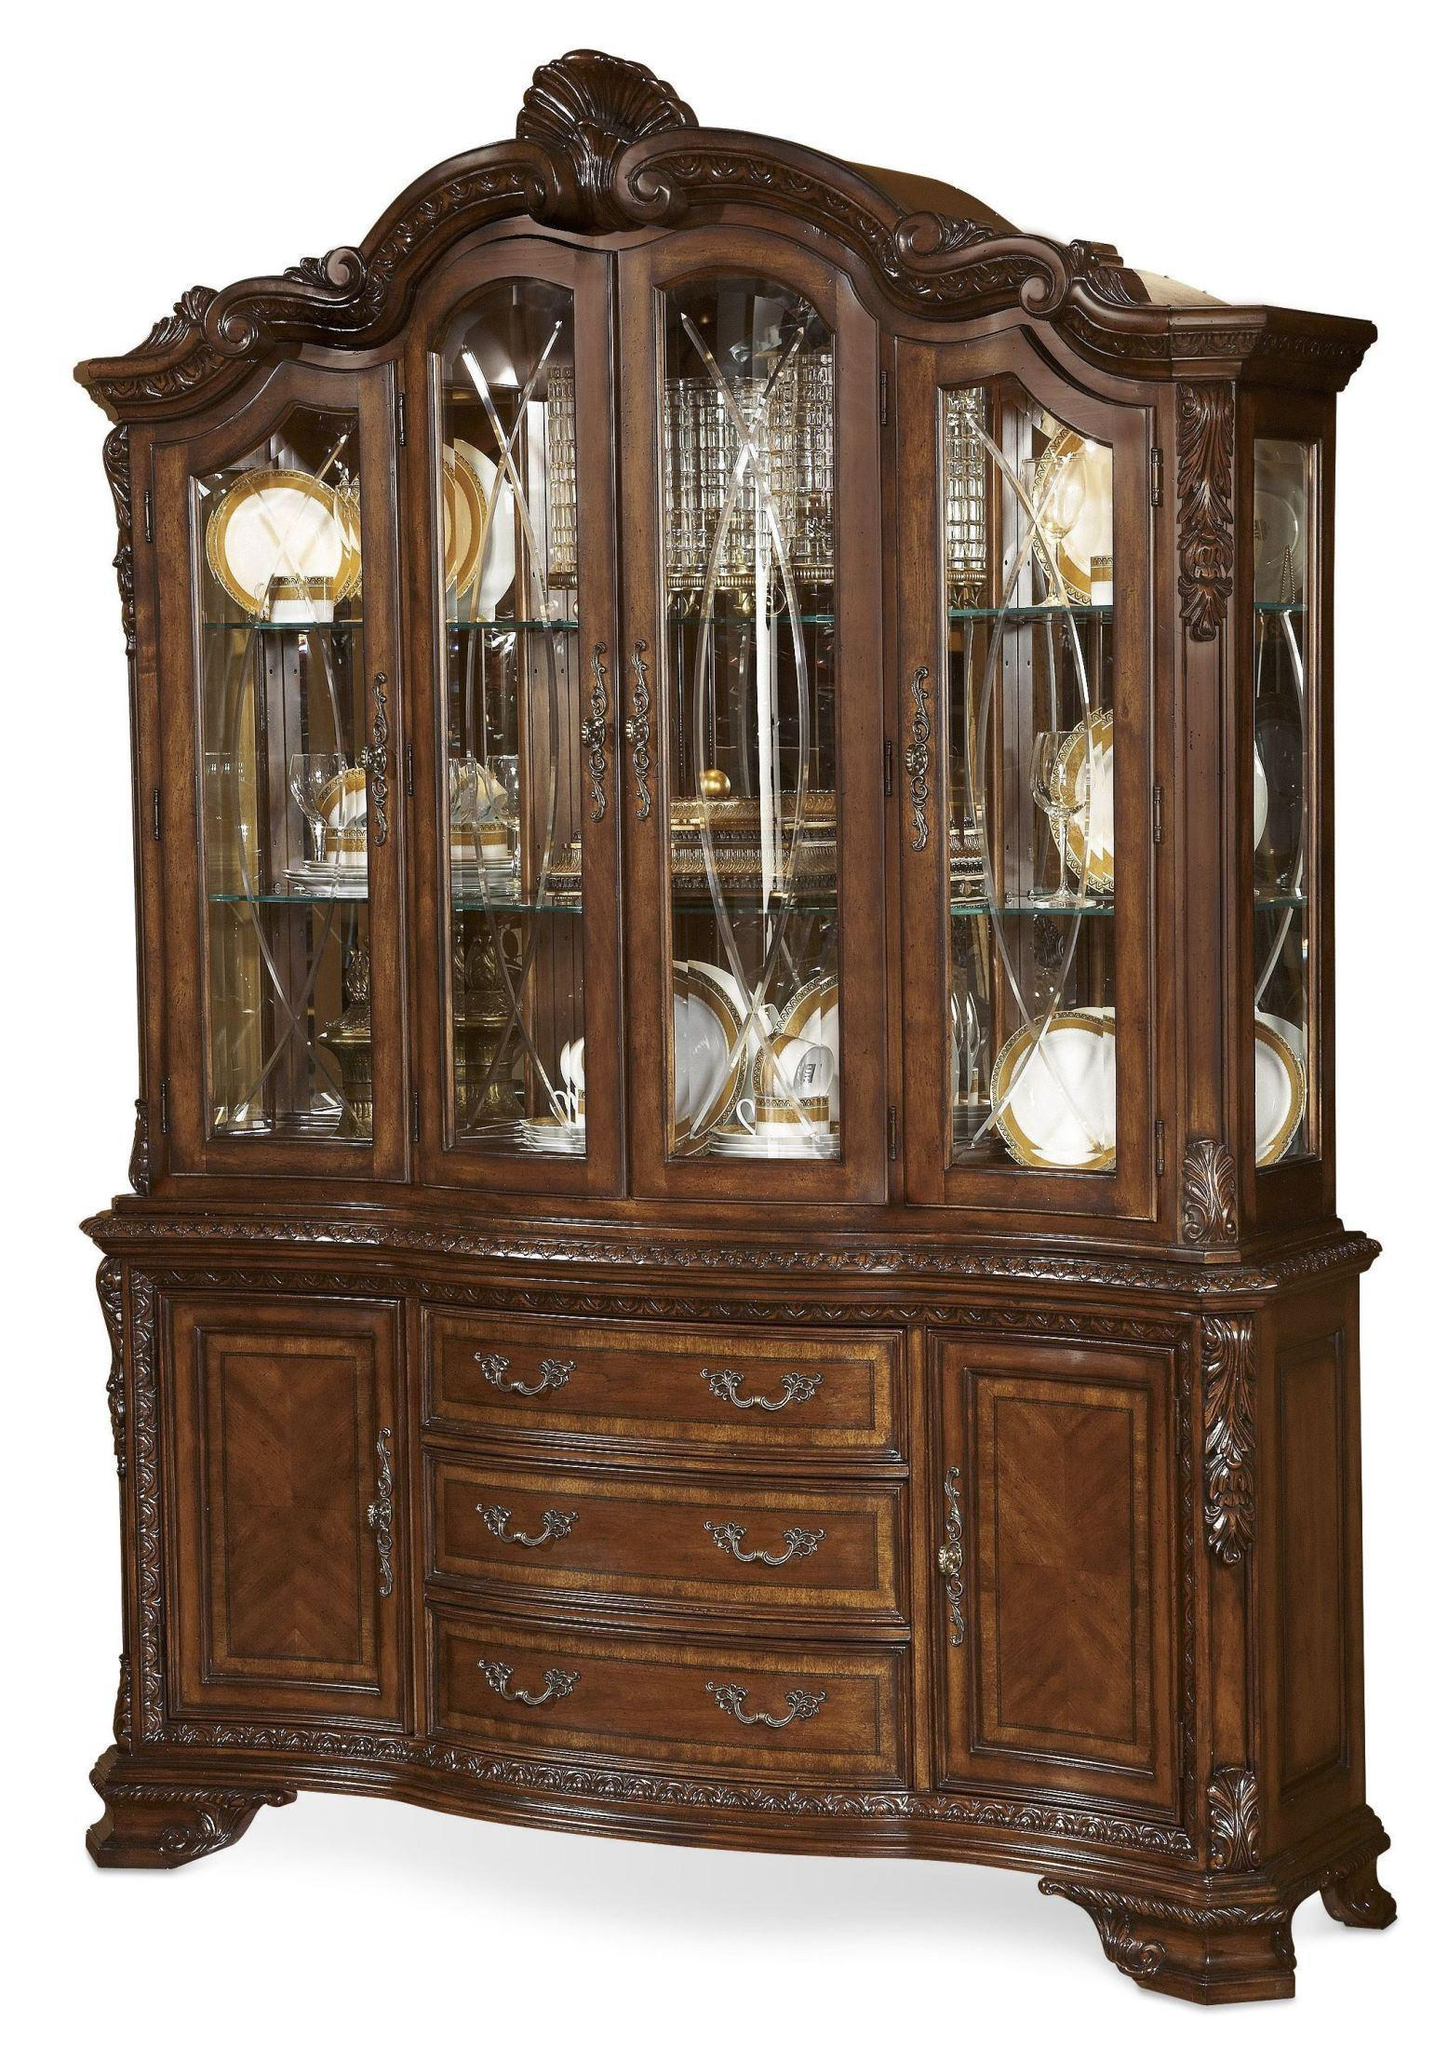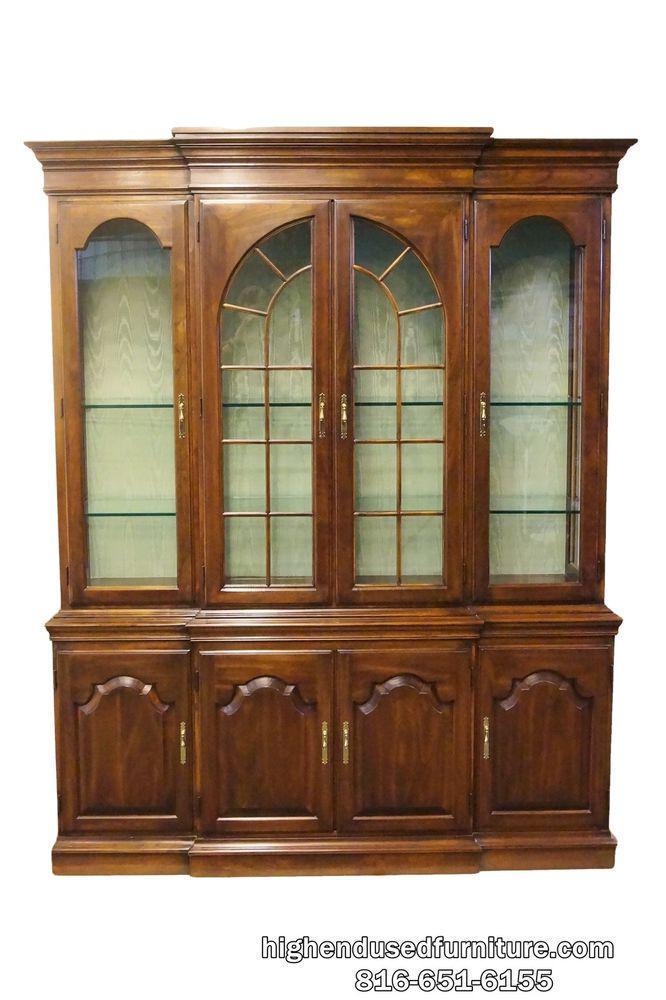The first image is the image on the left, the second image is the image on the right. Assess this claim about the two images: "The shelves on the left are full.". Correct or not? Answer yes or no. Yes. 